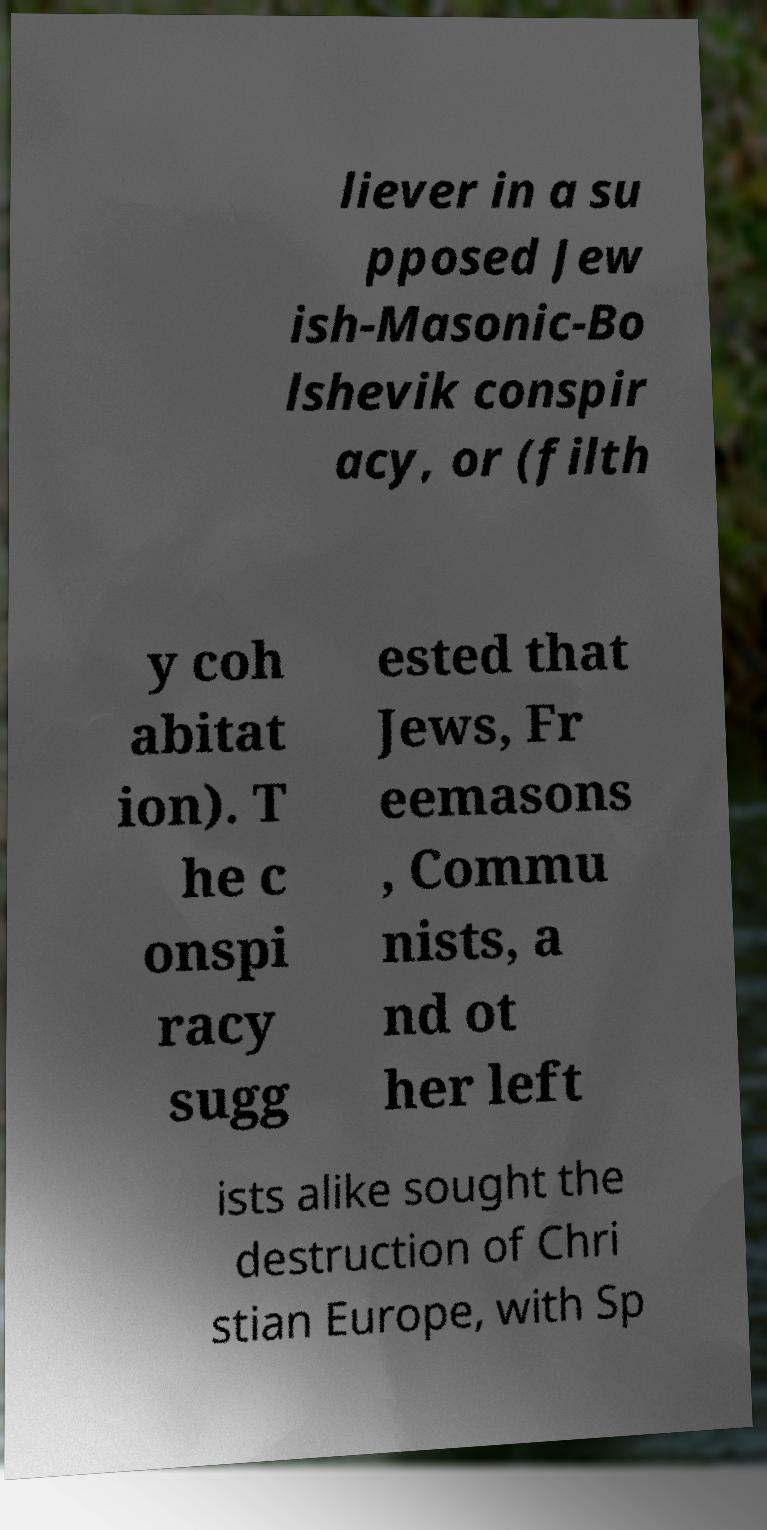Can you read and provide the text displayed in the image?This photo seems to have some interesting text. Can you extract and type it out for me? liever in a su pposed Jew ish-Masonic-Bo lshevik conspir acy, or (filth y coh abitat ion). T he c onspi racy sugg ested that Jews, Fr eemasons , Commu nists, a nd ot her left ists alike sought the destruction of Chri stian Europe, with Sp 